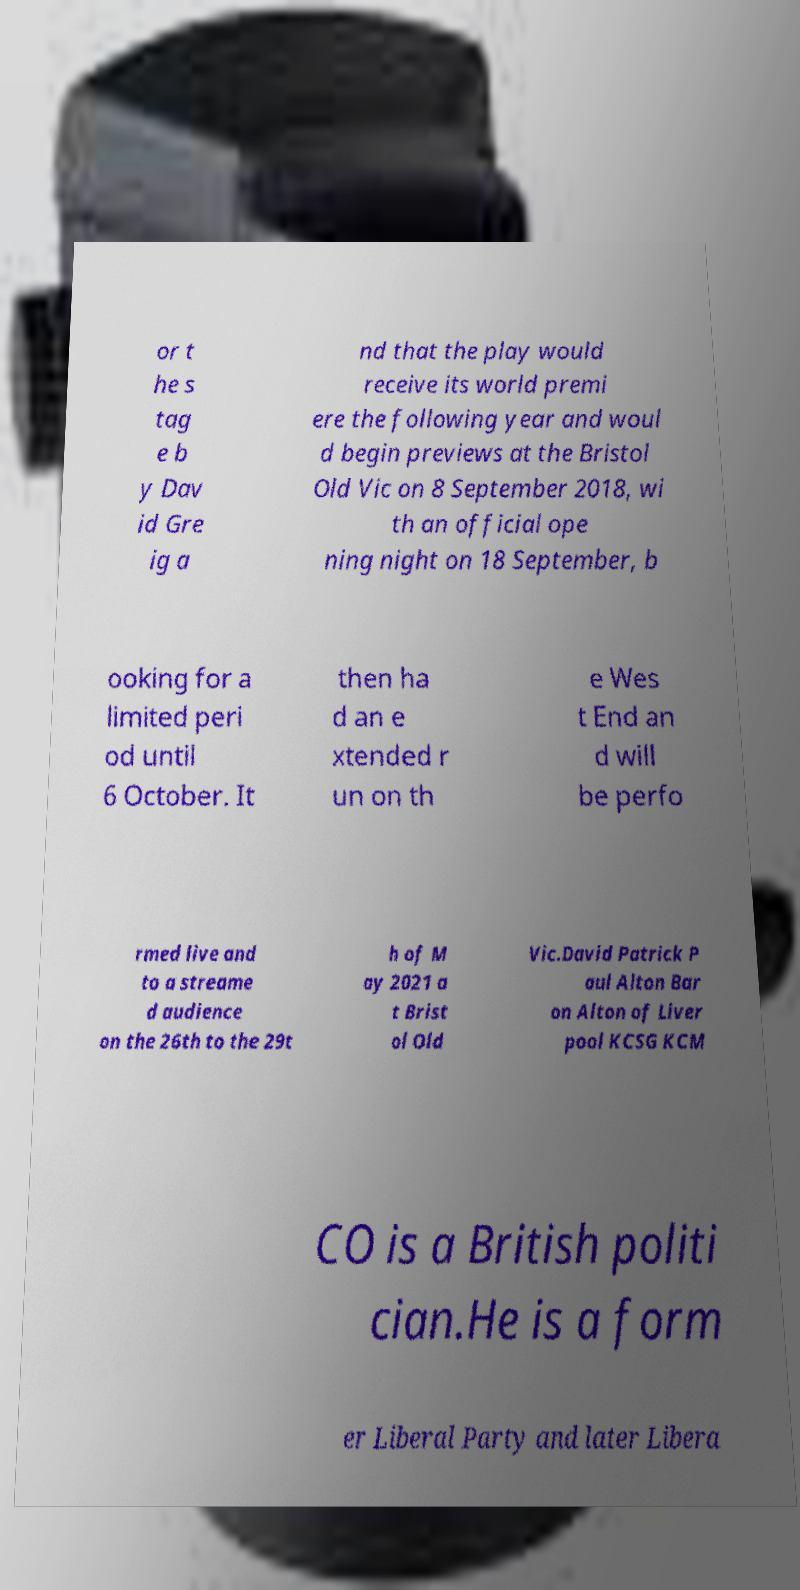Could you assist in decoding the text presented in this image and type it out clearly? or t he s tag e b y Dav id Gre ig a nd that the play would receive its world premi ere the following year and woul d begin previews at the Bristol Old Vic on 8 September 2018, wi th an official ope ning night on 18 September, b ooking for a limited peri od until 6 October. It then ha d an e xtended r un on th e Wes t End an d will be perfo rmed live and to a streame d audience on the 26th to the 29t h of M ay 2021 a t Brist ol Old Vic.David Patrick P aul Alton Bar on Alton of Liver pool KCSG KCM CO is a British politi cian.He is a form er Liberal Party and later Libera 